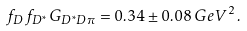Convert formula to latex. <formula><loc_0><loc_0><loc_500><loc_500>f _ { D } \, f _ { D ^ { * } } \, G _ { D ^ { * } D \pi } = 0 . 3 4 \pm 0 . 0 8 \, G e V ^ { 2 } \, .</formula> 